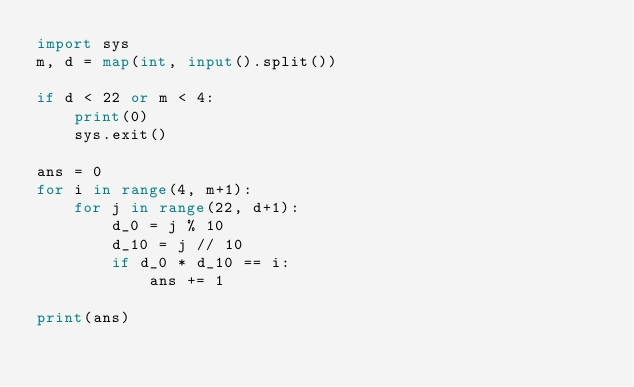<code> <loc_0><loc_0><loc_500><loc_500><_Python_>import sys
m, d = map(int, input().split())

if d < 22 or m < 4:
    print(0)
    sys.exit()

ans = 0
for i in range(4, m+1):
    for j in range(22, d+1):
        d_0 = j % 10
        d_10 = j // 10
        if d_0 * d_10 == i:
            ans += 1

print(ans)</code> 